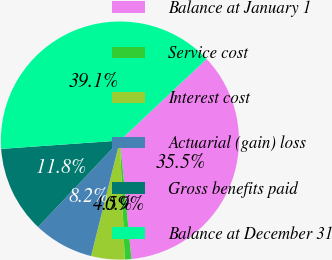Convert chart to OTSL. <chart><loc_0><loc_0><loc_500><loc_500><pie_chart><fcel>Balance at January 1<fcel>Service cost<fcel>Interest cost<fcel>Actuarial (gain) loss<fcel>Gross benefits paid<fcel>Balance at December 31<nl><fcel>35.47%<fcel>0.9%<fcel>4.54%<fcel>8.17%<fcel>11.81%<fcel>39.11%<nl></chart> 